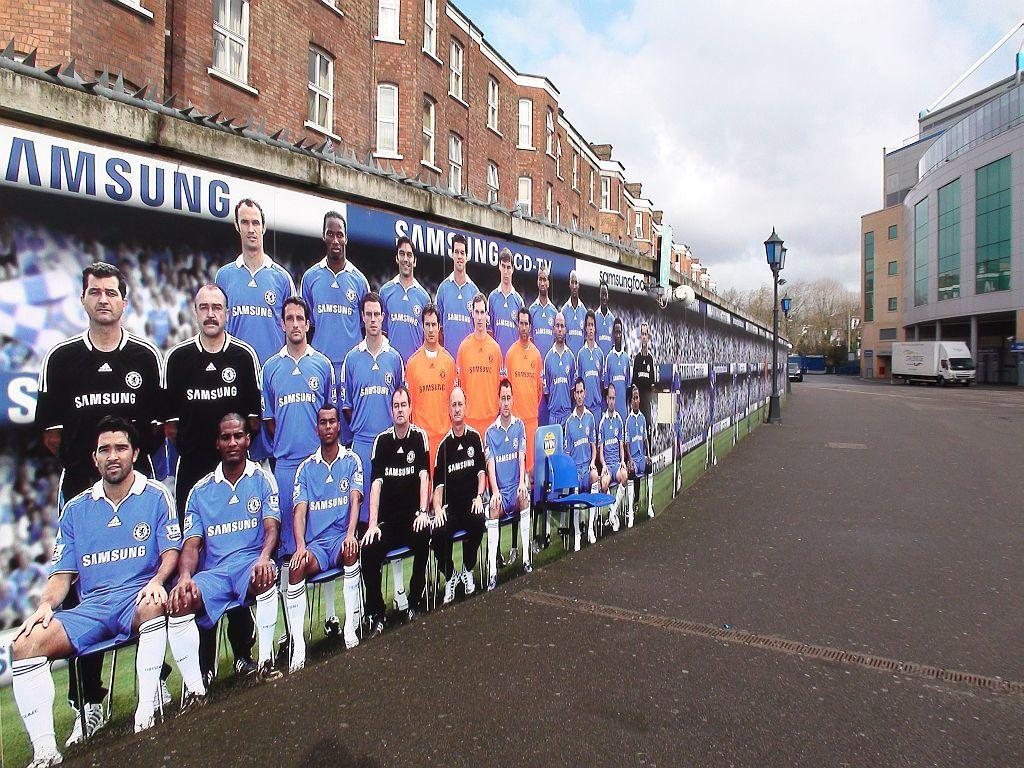Provide a one-sentence caption for the provided image. A large group of cardboard people wearing Samsung apparel. 